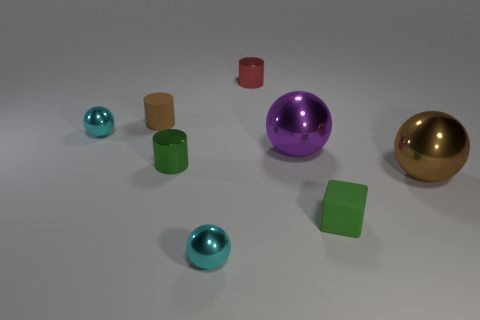There is a green thing that is the same material as the small brown cylinder; what is its size?
Your response must be concise. Small. What number of other metallic objects have the same shape as the brown shiny thing?
Offer a terse response. 3. There is a metal cylinder in front of the tiny cyan ball behind the large brown metal sphere; what size is it?
Keep it short and to the point. Small. There is a green cube that is the same size as the green cylinder; what is it made of?
Offer a terse response. Rubber. Is there a tiny cylinder that has the same material as the small block?
Make the answer very short. Yes. There is a metallic thing to the left of the matte thing left of the cyan sphere that is in front of the green matte cube; what is its color?
Your answer should be compact. Cyan. There is a metallic ball in front of the small green matte cube; does it have the same color as the small metal sphere that is behind the small green metallic thing?
Offer a very short reply. Yes. Is the number of small blocks on the right side of the tiny brown matte thing less than the number of cyan objects?
Provide a short and direct response. Yes. What number of brown spheres are there?
Give a very brief answer. 1. Do the brown shiny thing and the cyan object behind the rubber block have the same shape?
Your answer should be compact. Yes. 